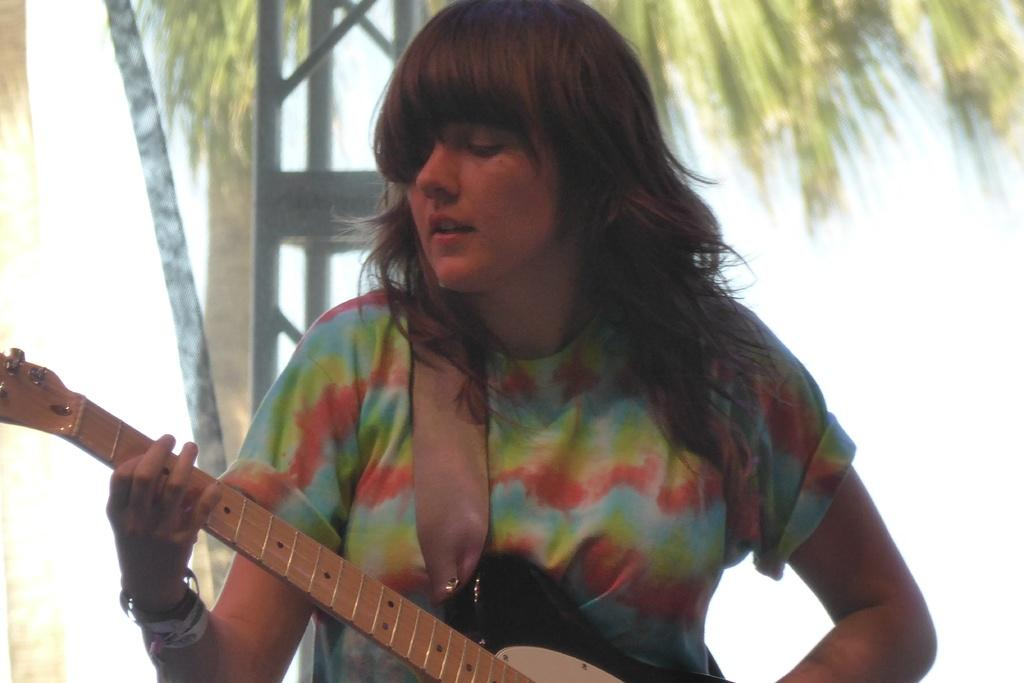What is the woman in the image doing? The woman is playing the guitar. What is the woman wearing in the image? The woman is wearing a colorful T-shirt. What can be seen in the background of the image? There is a tree visible in the background of the image. What type of beast can be seen walking down the alley in the image? There is no alley or beast present in the image. Is there a sidewalk visible in the image? There is no sidewalk mentioned or visible in the image. 